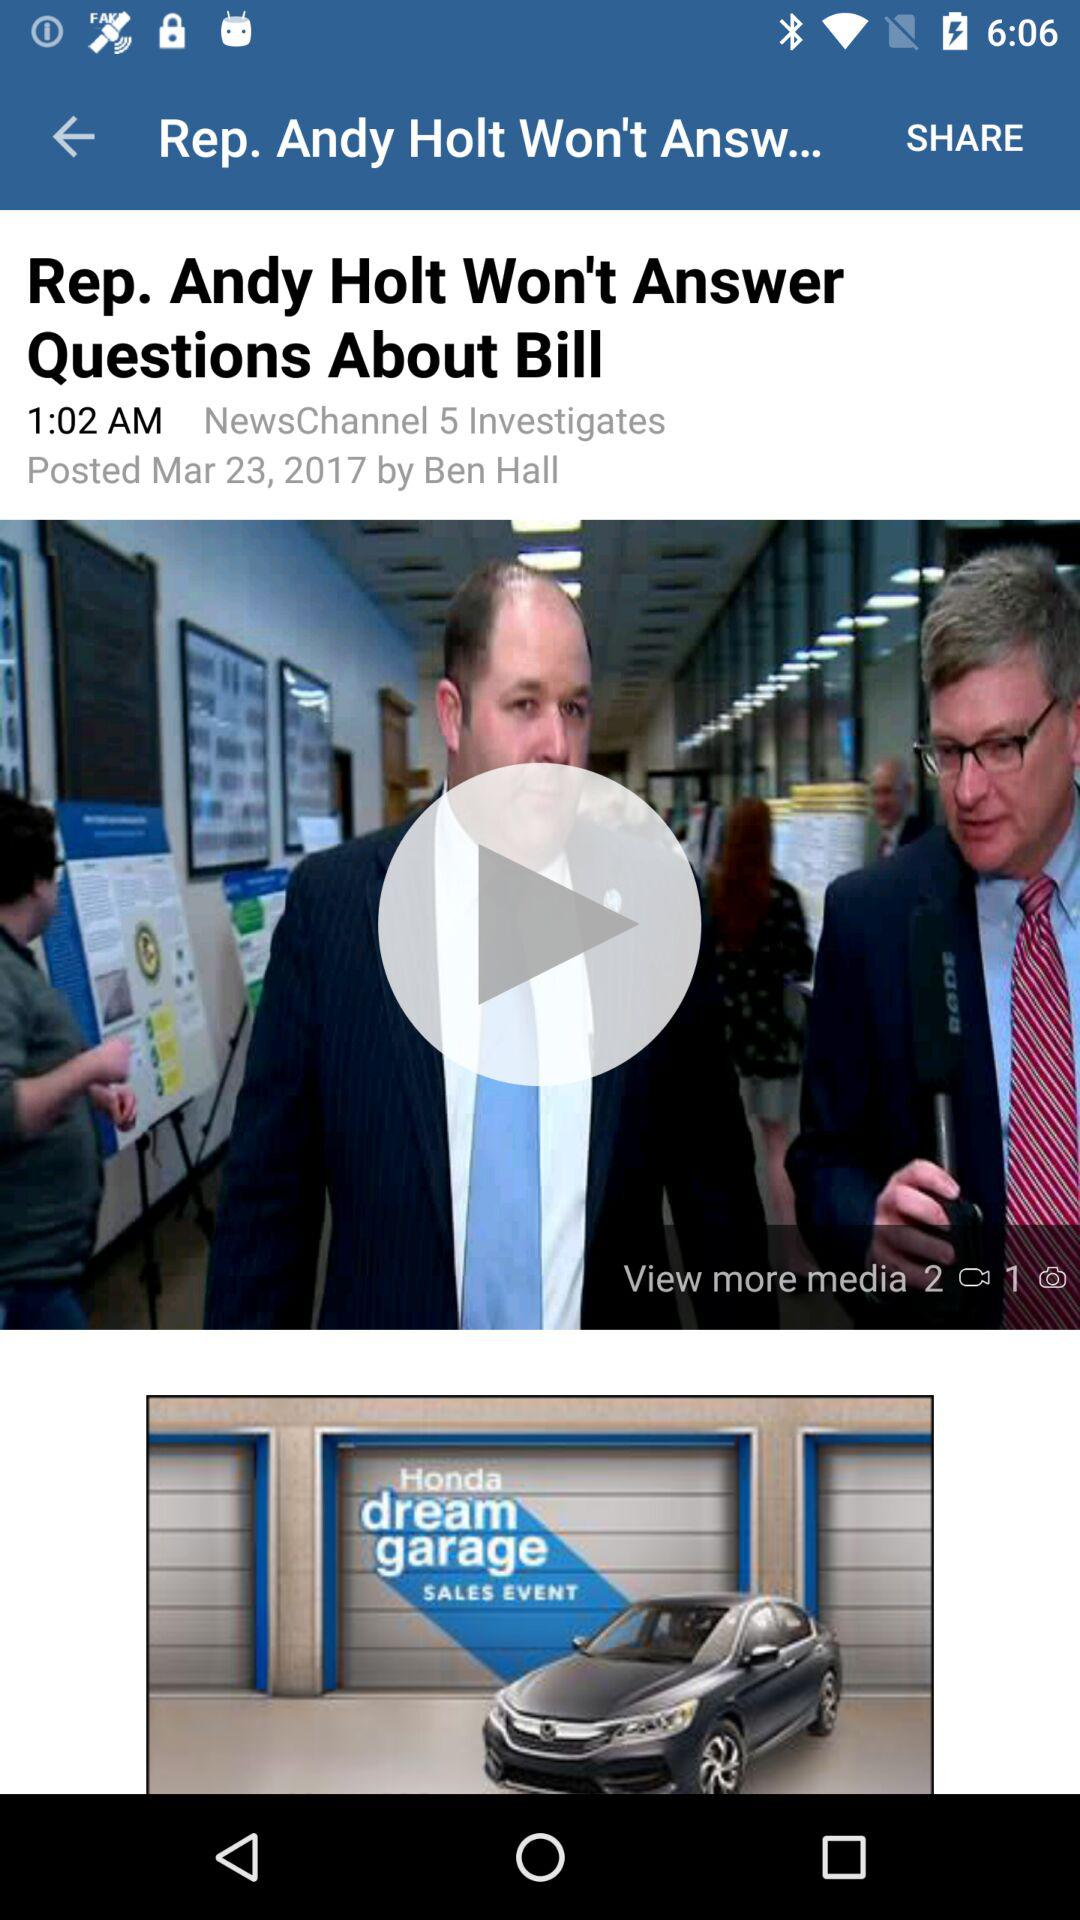On what day of the week was the article posted?
When the provided information is insufficient, respond with <no answer>. <no answer> 